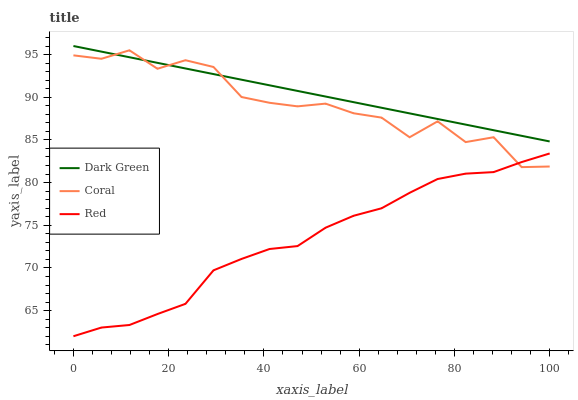Does Red have the minimum area under the curve?
Answer yes or no. Yes. Does Dark Green have the maximum area under the curve?
Answer yes or no. Yes. Does Dark Green have the minimum area under the curve?
Answer yes or no. No. Does Red have the maximum area under the curve?
Answer yes or no. No. Is Dark Green the smoothest?
Answer yes or no. Yes. Is Coral the roughest?
Answer yes or no. Yes. Is Red the smoothest?
Answer yes or no. No. Is Red the roughest?
Answer yes or no. No. Does Red have the lowest value?
Answer yes or no. Yes. Does Dark Green have the lowest value?
Answer yes or no. No. Does Dark Green have the highest value?
Answer yes or no. Yes. Does Red have the highest value?
Answer yes or no. No. Is Red less than Dark Green?
Answer yes or no. Yes. Is Dark Green greater than Red?
Answer yes or no. Yes. Does Coral intersect Dark Green?
Answer yes or no. Yes. Is Coral less than Dark Green?
Answer yes or no. No. Is Coral greater than Dark Green?
Answer yes or no. No. Does Red intersect Dark Green?
Answer yes or no. No. 